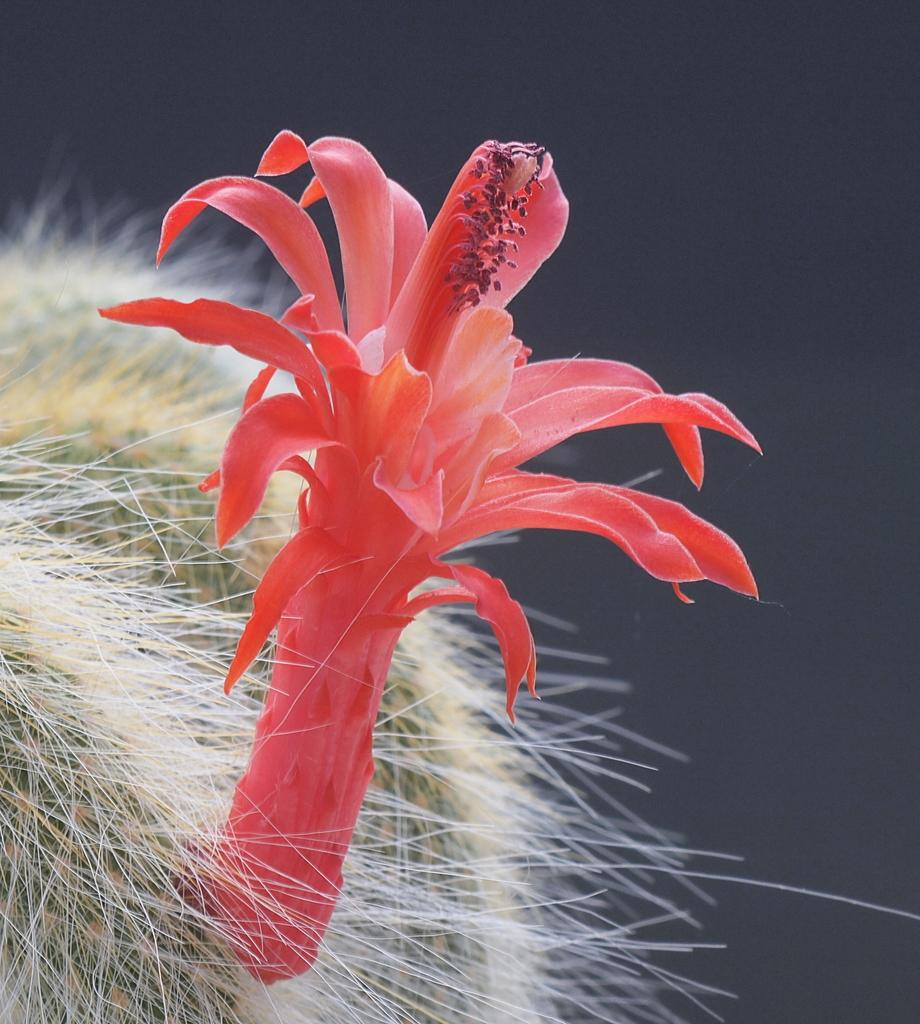What type of plant is featured in the image? There is a flower in the image, which is associated with a cactus plant. How many eyes can be seen on the flower in the image? There are no eyes visible on the flower in the image, as flowers do not have eyes. 